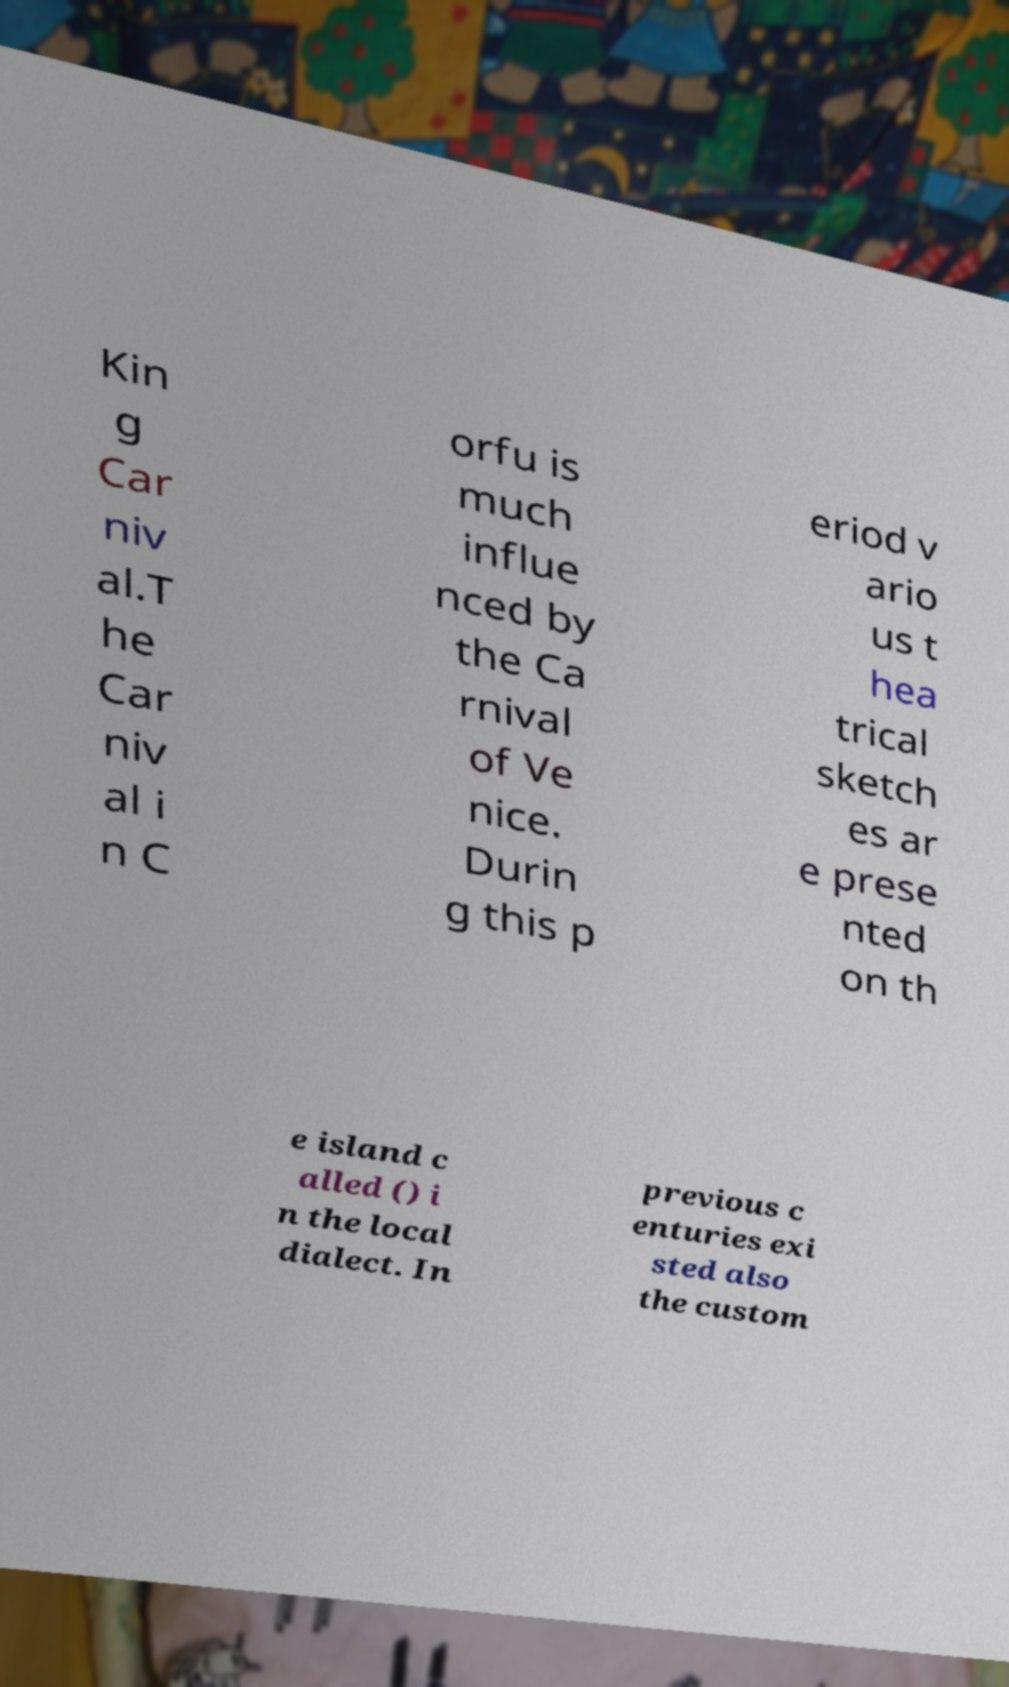Can you read and provide the text displayed in the image?This photo seems to have some interesting text. Can you extract and type it out for me? Kin g Car niv al.T he Car niv al i n C orfu is much influe nced by the Ca rnival of Ve nice. Durin g this p eriod v ario us t hea trical sketch es ar e prese nted on th e island c alled () i n the local dialect. In previous c enturies exi sted also the custom 